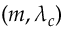Convert formula to latex. <formula><loc_0><loc_0><loc_500><loc_500>( m , \lambda _ { c } )</formula> 